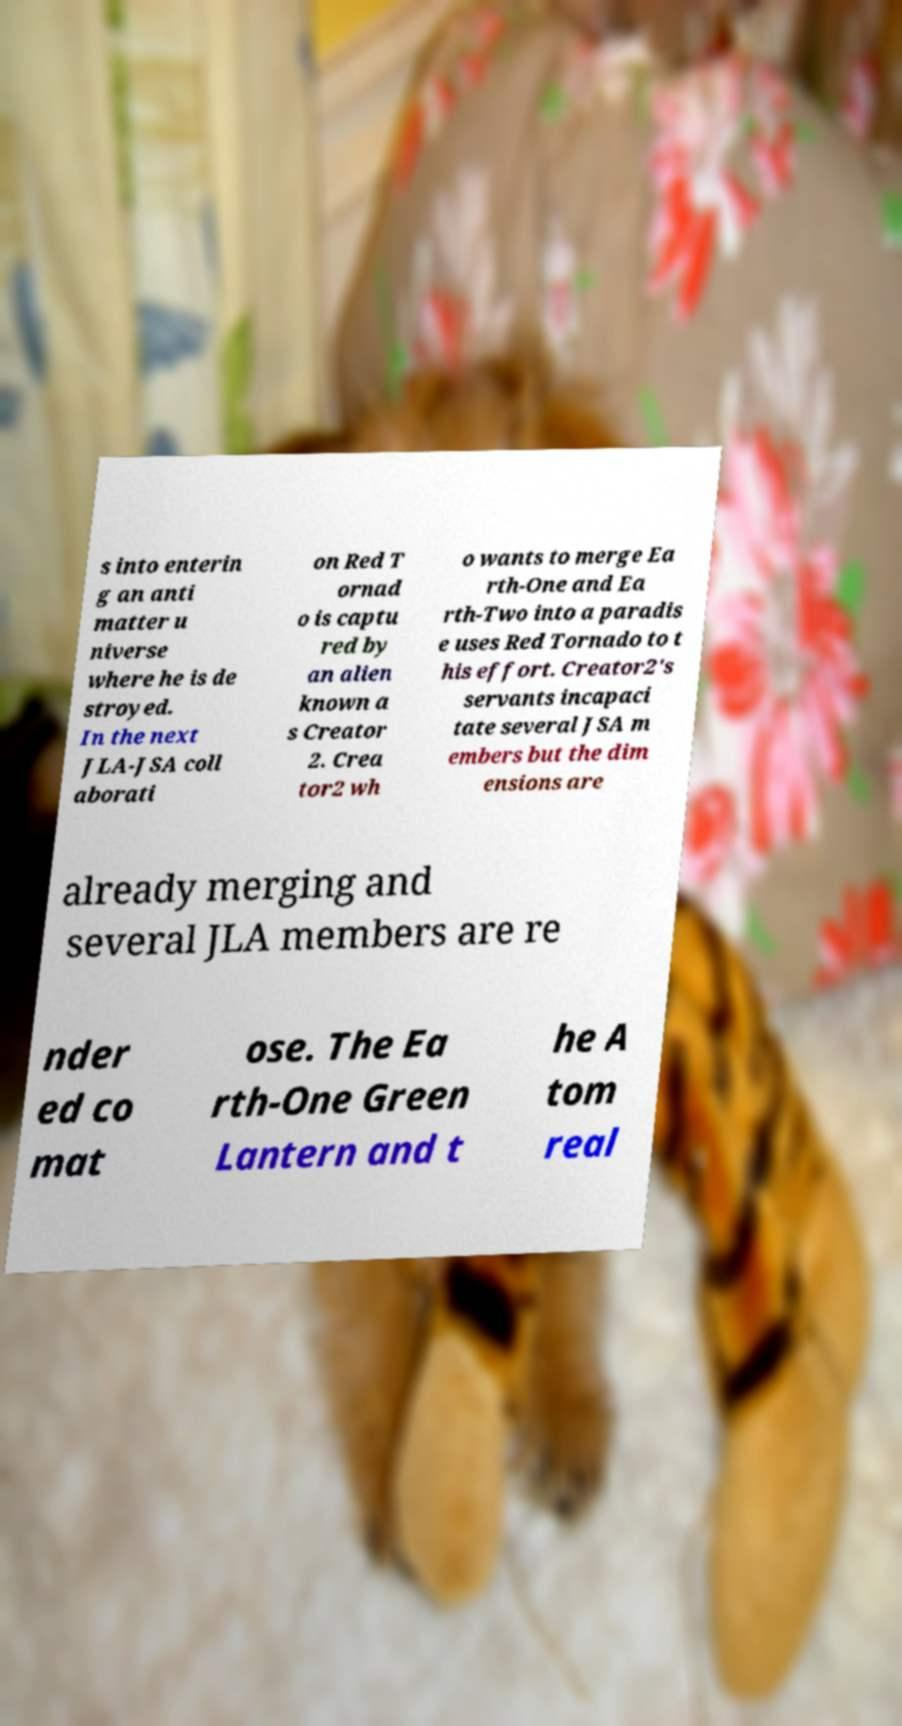I need the written content from this picture converted into text. Can you do that? s into enterin g an anti matter u niverse where he is de stroyed. In the next JLA-JSA coll aborati on Red T ornad o is captu red by an alien known a s Creator 2. Crea tor2 wh o wants to merge Ea rth-One and Ea rth-Two into a paradis e uses Red Tornado to t his effort. Creator2's servants incapaci tate several JSA m embers but the dim ensions are already merging and several JLA members are re nder ed co mat ose. The Ea rth-One Green Lantern and t he A tom real 